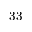Convert formula to latex. <formula><loc_0><loc_0><loc_500><loc_500>3 3</formula> 